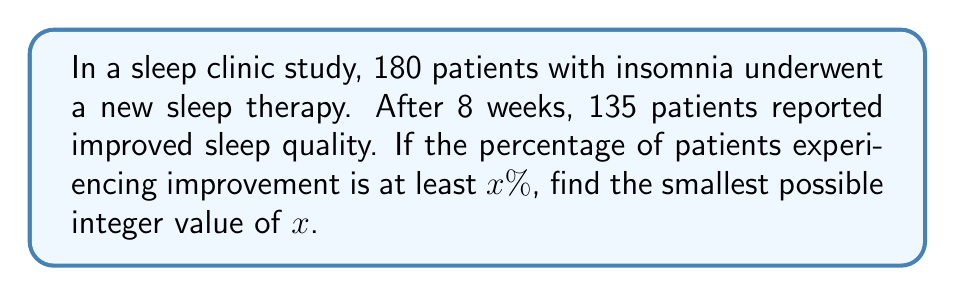Help me with this question. To solve this problem, we'll follow these steps:

1. Calculate the exact percentage of patients who improved:
   $$\text{Percentage} = \frac{\text{Number of improved patients}}{\text{Total number of patients}} \times 100\%$$
   $$\text{Percentage} = \frac{135}{180} \times 100\% = 75\%$$

2. Since the question asks for the smallest possible integer value of $x$ where the percentage is at least $x\%$, we need to round up this percentage to the nearest integer.

3. The calculated percentage (75%) is already an integer, so we don't need to round up.

4. Therefore, the smallest possible integer value of $x$ that satisfies the condition is 75.
Answer: $x = 75$ 